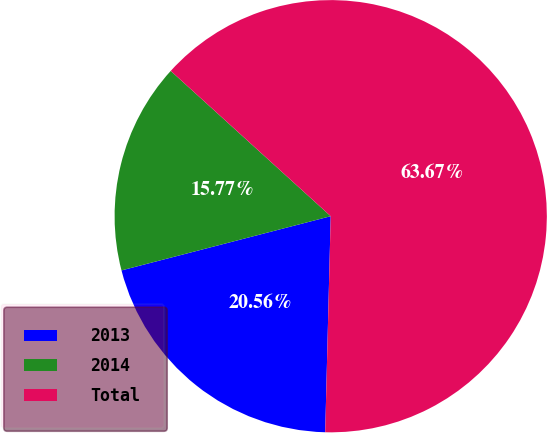Convert chart to OTSL. <chart><loc_0><loc_0><loc_500><loc_500><pie_chart><fcel>2013<fcel>2014<fcel>Total<nl><fcel>20.56%<fcel>15.77%<fcel>63.67%<nl></chart> 